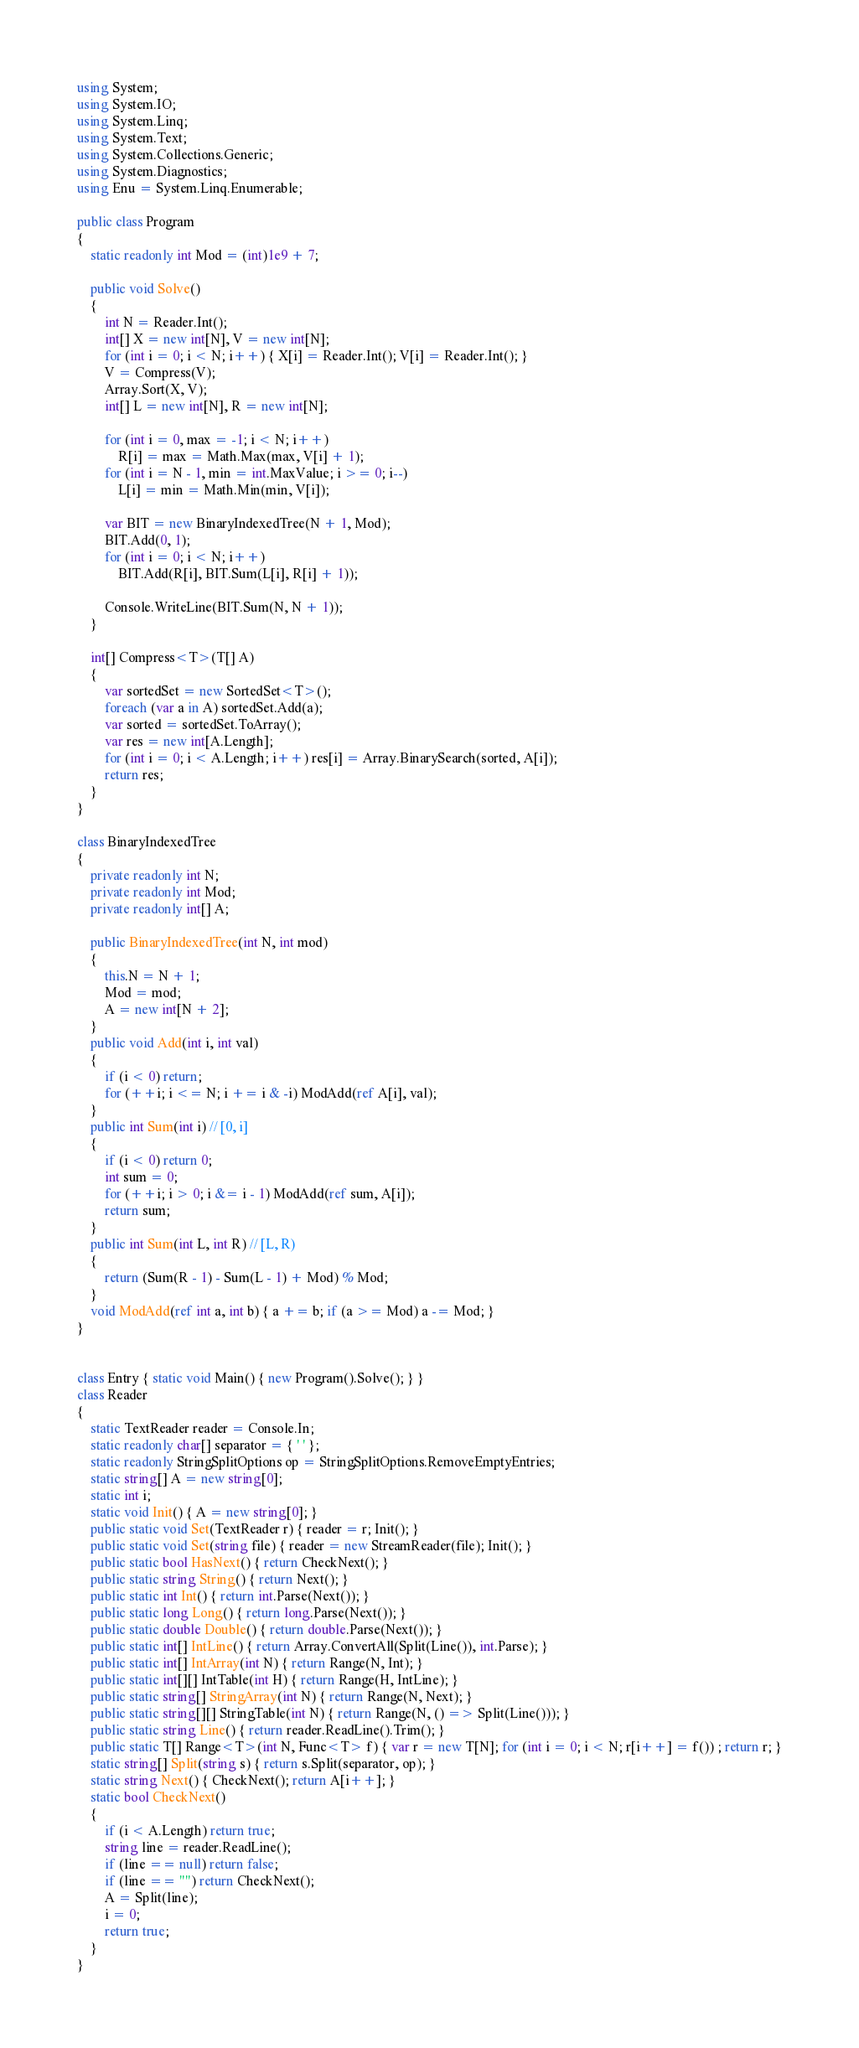Convert code to text. <code><loc_0><loc_0><loc_500><loc_500><_C#_>using System;
using System.IO;
using System.Linq;
using System.Text;
using System.Collections.Generic;
using System.Diagnostics;
using Enu = System.Linq.Enumerable;

public class Program
{
    static readonly int Mod = (int)1e9 + 7;

    public void Solve()
    {
        int N = Reader.Int();
        int[] X = new int[N], V = new int[N];
        for (int i = 0; i < N; i++) { X[i] = Reader.Int(); V[i] = Reader.Int(); }
        V = Compress(V);
        Array.Sort(X, V);
        int[] L = new int[N], R = new int[N];

        for (int i = 0, max = -1; i < N; i++)
            R[i] = max = Math.Max(max, V[i] + 1);
        for (int i = N - 1, min = int.MaxValue; i >= 0; i--)
            L[i] = min = Math.Min(min, V[i]);

        var BIT = new BinaryIndexedTree(N + 1, Mod);
        BIT.Add(0, 1);
        for (int i = 0; i < N; i++)
            BIT.Add(R[i], BIT.Sum(L[i], R[i] + 1));

        Console.WriteLine(BIT.Sum(N, N + 1));
    }

    int[] Compress<T>(T[] A)
    {
        var sortedSet = new SortedSet<T>();
        foreach (var a in A) sortedSet.Add(a);
        var sorted = sortedSet.ToArray();
        var res = new int[A.Length];
        for (int i = 0; i < A.Length; i++) res[i] = Array.BinarySearch(sorted, A[i]);
        return res;
    }
}

class BinaryIndexedTree
{
    private readonly int N;
    private readonly int Mod;
    private readonly int[] A;

    public BinaryIndexedTree(int N, int mod)
    {
        this.N = N + 1;
        Mod = mod;
        A = new int[N + 2];
    }
    public void Add(int i, int val)
    {
        if (i < 0) return;
        for (++i; i <= N; i += i & -i) ModAdd(ref A[i], val);
    }
    public int Sum(int i) // [0, i]
    {
        if (i < 0) return 0;
        int sum = 0;
        for (++i; i > 0; i &= i - 1) ModAdd(ref sum, A[i]);
        return sum;
    }
    public int Sum(int L, int R) // [L, R)
    {
        return (Sum(R - 1) - Sum(L - 1) + Mod) % Mod;
    }
    void ModAdd(ref int a, int b) { a += b; if (a >= Mod) a -= Mod; }
}


class Entry { static void Main() { new Program().Solve(); } }
class Reader
{
    static TextReader reader = Console.In;
    static readonly char[] separator = { ' ' };
    static readonly StringSplitOptions op = StringSplitOptions.RemoveEmptyEntries;
    static string[] A = new string[0];
    static int i;
    static void Init() { A = new string[0]; }
    public static void Set(TextReader r) { reader = r; Init(); }
    public static void Set(string file) { reader = new StreamReader(file); Init(); }
    public static bool HasNext() { return CheckNext(); }
    public static string String() { return Next(); }
    public static int Int() { return int.Parse(Next()); }
    public static long Long() { return long.Parse(Next()); }
    public static double Double() { return double.Parse(Next()); }
    public static int[] IntLine() { return Array.ConvertAll(Split(Line()), int.Parse); }
    public static int[] IntArray(int N) { return Range(N, Int); }
    public static int[][] IntTable(int H) { return Range(H, IntLine); }
    public static string[] StringArray(int N) { return Range(N, Next); }
    public static string[][] StringTable(int N) { return Range(N, () => Split(Line())); }
    public static string Line() { return reader.ReadLine().Trim(); }
    public static T[] Range<T>(int N, Func<T> f) { var r = new T[N]; for (int i = 0; i < N; r[i++] = f()) ; return r; }
    static string[] Split(string s) { return s.Split(separator, op); }
    static string Next() { CheckNext(); return A[i++]; }
    static bool CheckNext()
    {
        if (i < A.Length) return true;
        string line = reader.ReadLine();
        if (line == null) return false;
        if (line == "") return CheckNext();
        A = Split(line);
        i = 0;
        return true;
    }
}</code> 